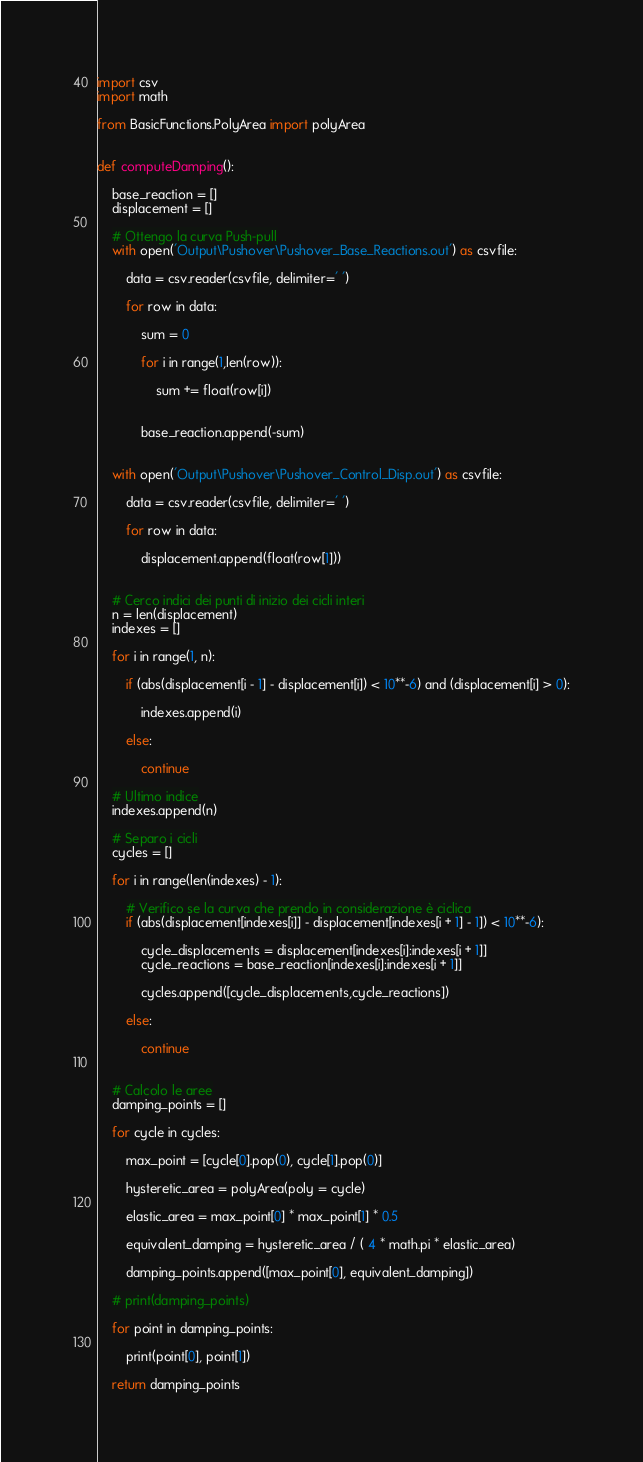Convert code to text. <code><loc_0><loc_0><loc_500><loc_500><_Python_>import csv
import math

from BasicFunctions.PolyArea import polyArea


def computeDamping():

    base_reaction = []
    displacement = []

    # Ottengo la curva Push-pull
    with open('Output\Pushover\Pushover_Base_Reactions.out') as csvfile:

        data = csv.reader(csvfile, delimiter=' ')

        for row in data:
            
            sum = 0

            for i in range(1,len(row)):

                sum += float(row[i])
            

            base_reaction.append(-sum)


    with open('Output\Pushover\Pushover_Control_Disp.out') as csvfile:

        data = csv.reader(csvfile, delimiter=' ')

        for row in data:
            
            displacement.append(float(row[1]))


    # Cerco indici dei punti di inizio dei cicli interi
    n = len(displacement)
    indexes = []

    for i in range(1, n):

        if (abs(displacement[i - 1] - displacement[i]) < 10**-6) and (displacement[i] > 0):

            indexes.append(i)
        
        else:

            continue

    # Ultimo indice
    indexes.append(n)

    # Separo i cicli
    cycles = []

    for i in range(len(indexes) - 1):

        # Verifico se la curva che prendo in considerazione è ciclica
        if (abs(displacement[indexes[i]] - displacement[indexes[i + 1] - 1]) < 10**-6):

            cycle_displacements = displacement[indexes[i]:indexes[i + 1]]
            cycle_reactions = base_reaction[indexes[i]:indexes[i + 1]]

            cycles.append([cycle_displacements,cycle_reactions])
        
        else:

            continue
        

    # Calcolo le aree
    damping_points = []

    for cycle in cycles:

        max_point = [cycle[0].pop(0), cycle[1].pop(0)]

        hysteretic_area = polyArea(poly = cycle)

        elastic_area = max_point[0] * max_point[1] * 0.5
        
        equivalent_damping = hysteretic_area / ( 4 * math.pi * elastic_area)

        damping_points.append([max_point[0], equivalent_damping])

    # print(damping_points)

    for point in damping_points:

        print(point[0], point[1])

    return damping_points

</code> 